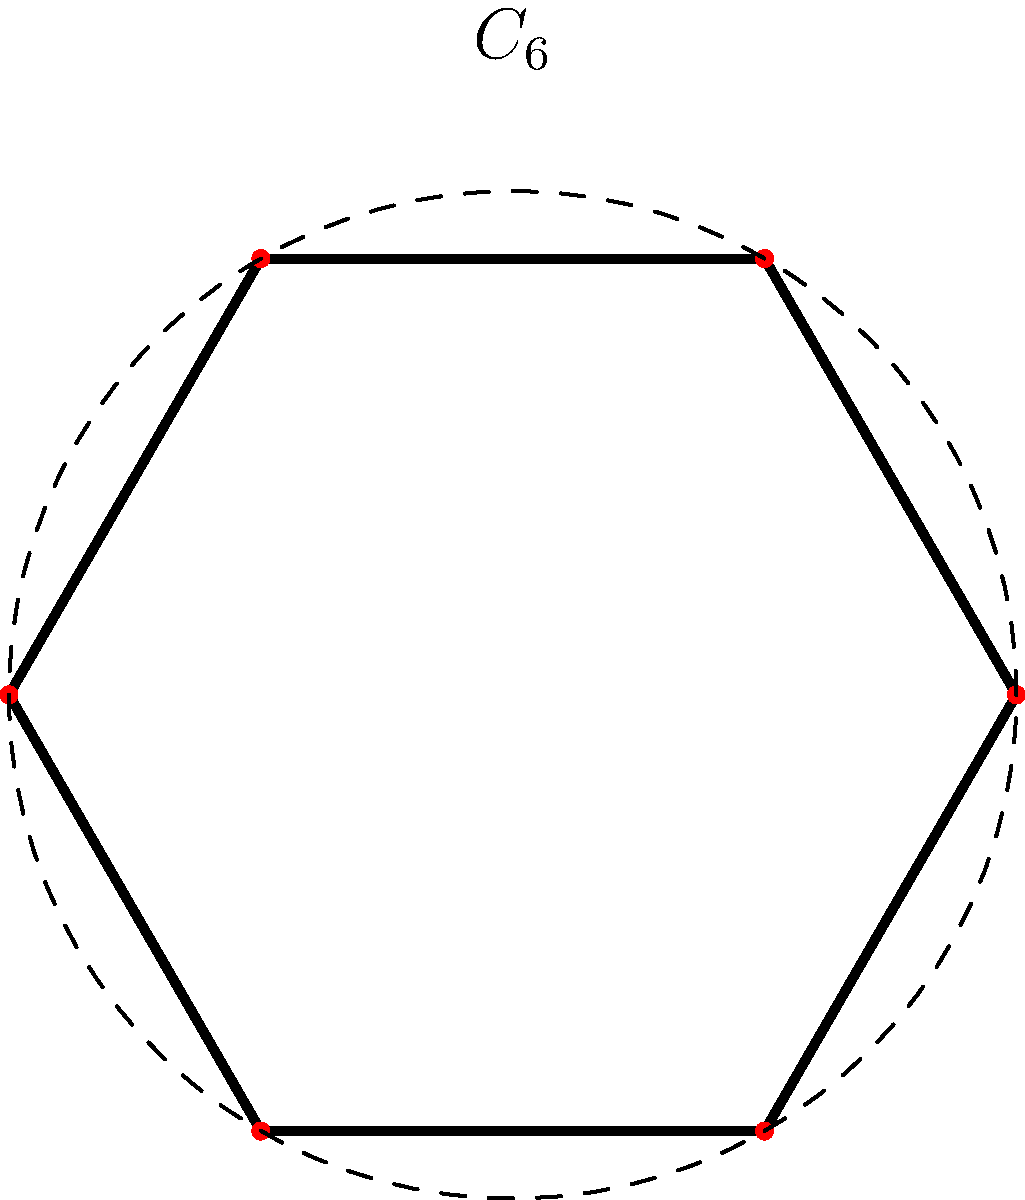A rare hexagonal sculpture base exhibits $C_6$ rotational symmetry. If the group of rotational symmetries is isomorphic to $\mathbb{Z}_6$, how many unique ways can you mark one vertex of the base to break all rotational symmetries except the identity? To solve this problem, we need to consider the following steps:

1) The group of rotational symmetries $C_6$ is isomorphic to $\mathbb{Z}_6$, which means it has 6 elements: rotations by 0°, 60°, 120°, 180°, 240°, and 300°.

2) We want to break all symmetries except the identity (0° rotation). This means that after marking a vertex, rotating the base should never result in the same configuration.

3) If we mark one vertex, we have 6 choices for where to place the mark.

4) However, marking any vertex will break all rotational symmetries except the identity. This is because rotating a marked vertex to any other position will result in a different configuration.

5) Therefore, marking any of the 6 vertices will achieve our goal.

6) Since all 6 choices lead to the same result (breaking all non-identity symmetries), there is only 1 unique way to mark the base to achieve this goal.
Answer: 1 